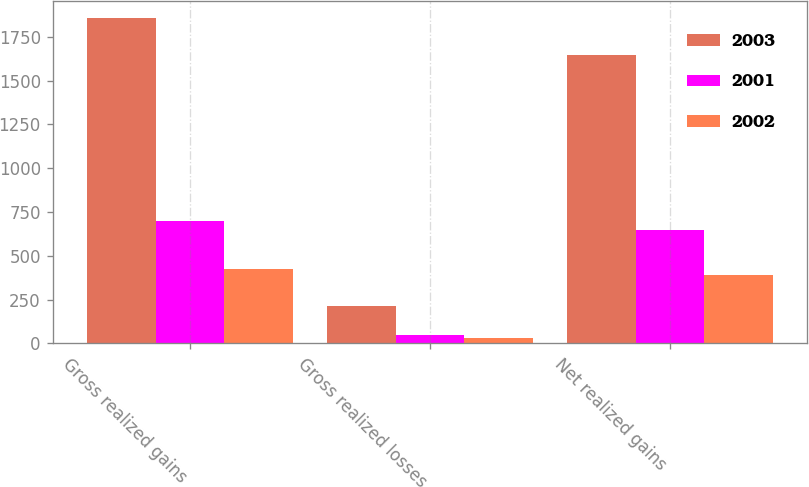Convert chart. <chart><loc_0><loc_0><loc_500><loc_500><stacked_bar_chart><ecel><fcel>Gross realized gains<fcel>Gross realized losses<fcel>Net realized gains<nl><fcel>2003<fcel>1859<fcel>213<fcel>1646<nl><fcel>2001<fcel>698<fcel>49<fcel>649<nl><fcel>2002<fcel>424<fcel>34<fcel>390<nl></chart> 